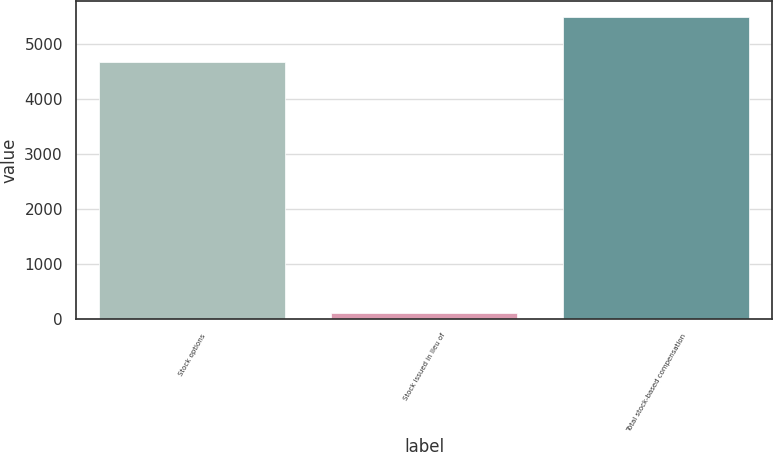<chart> <loc_0><loc_0><loc_500><loc_500><bar_chart><fcel>Stock options<fcel>Stock issued in lieu of<fcel>Total stock-based compensation<nl><fcel>4671<fcel>122<fcel>5498<nl></chart> 